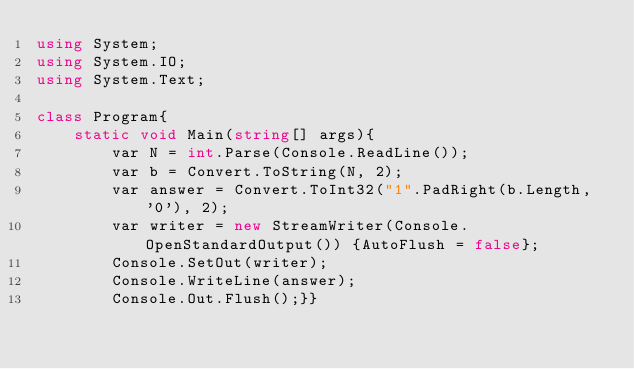<code> <loc_0><loc_0><loc_500><loc_500><_C#_>using System;
using System.IO;
using System.Text;

class Program{
    static void Main(string[] args){
        var N = int.Parse(Console.ReadLine());
        var b = Convert.ToString(N, 2);
        var answer = Convert.ToInt32("1".PadRight(b.Length, '0'), 2);
        var writer = new StreamWriter(Console.OpenStandardOutput()) {AutoFlush = false};
        Console.SetOut(writer);
        Console.WriteLine(answer);
        Console.Out.Flush();}}</code> 